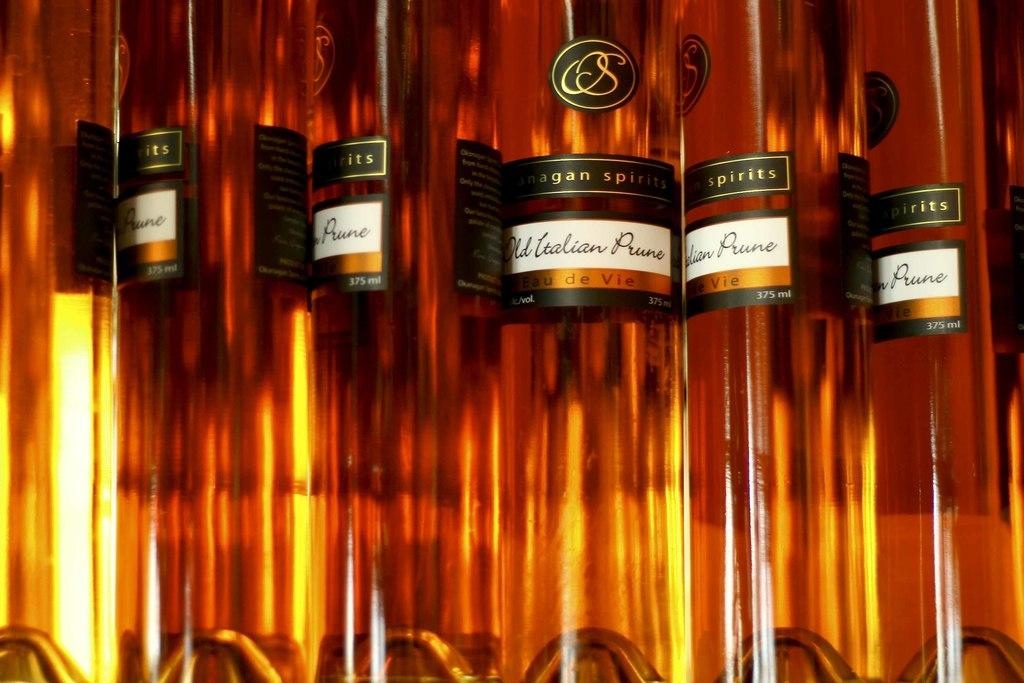What type of beverage containers are present in the image? There are wine bottles in the image. Can you hear the sound of steam coming from the wine bottles in the image? There is no sound or steam present in the image, as it features wine bottles. 